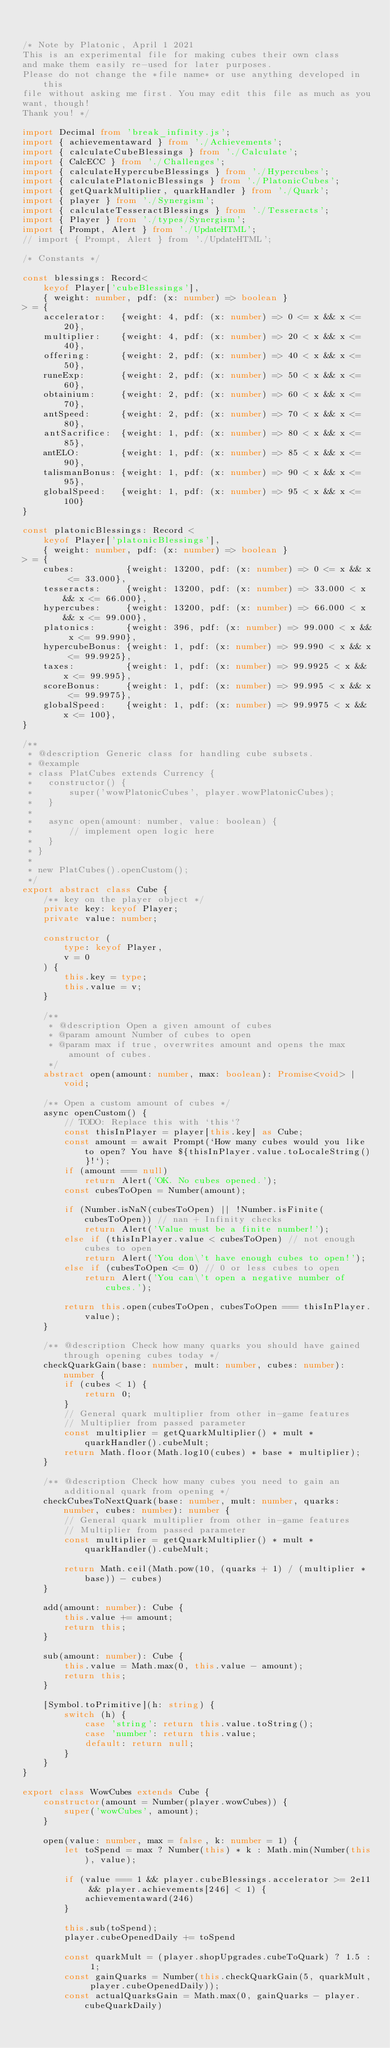Convert code to text. <code><loc_0><loc_0><loc_500><loc_500><_TypeScript_>

/* Note by Platonic, April 1 2021
This is an experimental file for making cubes their own class
and make them easily re-used for later purposes.
Please do not change the *file name* or use anything developed in this
file without asking me first. You may edit this file as much as you
want, though!
Thank you! */

import Decimal from 'break_infinity.js';
import { achievementaward } from './Achievements';
import { calculateCubeBlessings } from './Calculate';
import { CalcECC } from './Challenges';
import { calculateHypercubeBlessings } from './Hypercubes';
import { calculatePlatonicBlessings } from './PlatonicCubes';
import { getQuarkMultiplier, quarkHandler } from './Quark';
import { player } from './Synergism';
import { calculateTesseractBlessings } from './Tesseracts';
import { Player } from './types/Synergism';
import { Prompt, Alert } from './UpdateHTML';
// import { Prompt, Alert } from './UpdateHTML';

/* Constants */

const blessings: Record<
    keyof Player['cubeBlessings'], 
    { weight: number, pdf: (x: number) => boolean }
> = {
    accelerator:   {weight: 4, pdf: (x: number) => 0 <= x && x <= 20},
    multiplier:    {weight: 4, pdf: (x: number) => 20 < x && x <= 40},
    offering:      {weight: 2, pdf: (x: number) => 40 < x && x <= 50},
    runeExp:       {weight: 2, pdf: (x: number) => 50 < x && x <= 60},
    obtainium:     {weight: 2, pdf: (x: number) => 60 < x && x <= 70},
    antSpeed:      {weight: 2, pdf: (x: number) => 70 < x && x <= 80},
    antSacrifice:  {weight: 1, pdf: (x: number) => 80 < x && x <= 85},
    antELO:        {weight: 1, pdf: (x: number) => 85 < x && x <= 90},
    talismanBonus: {weight: 1, pdf: (x: number) => 90 < x && x <= 95},
    globalSpeed:   {weight: 1, pdf: (x: number) => 95 < x && x <= 100}
}

const platonicBlessings: Record <
    keyof Player['platonicBlessings'],
    { weight: number, pdf: (x: number) => boolean }
> = {
    cubes:          {weight: 13200, pdf: (x: number) => 0 <= x && x <= 33.000},
    tesseracts:     {weight: 13200, pdf: (x: number) => 33.000 < x && x <= 66.000},
    hypercubes:     {weight: 13200, pdf: (x: number) => 66.000 < x && x <= 99.000},
    platonics:      {weight: 396, pdf: (x: number) => 99.000 < x && x <= 99.990},
    hypercubeBonus: {weight: 1, pdf: (x: number) => 99.990 < x && x <= 99.9925},
    taxes:          {weight: 1, pdf: (x: number) => 99.9925 < x && x <= 99.995},
    scoreBonus:     {weight: 1, pdf: (x: number) => 99.995 < x && x <= 99.9975},
    globalSpeed:    {weight: 1, pdf: (x: number) => 99.9975 < x && x <= 100},
}

/**
 * @description Generic class for handling cube subsets.
 * @example
 * class PlatCubes extends Currency {
 *   constructor() {
 *       super('wowPlatonicCubes', player.wowPlatonicCubes);
 *   }
 *
 *   async open(amount: number, value: boolean) {
 *       // implement open logic here
 *   }
 * }
 * 
 * new PlatCubes().openCustom(); 
 */
export abstract class Cube {
    /** key on the player object */
    private key: keyof Player;
    private value: number;

    constructor (
        type: keyof Player,
        v = 0
    ) {
        this.key = type;
        this.value = v;
    }

    /**
     * @description Open a given amount of cubes
     * @param amount Number of cubes to open
     * @param max if true, overwrites amount and opens the max amount of cubes.
     */
    abstract open(amount: number, max: boolean): Promise<void> | void;

    /** Open a custom amount of cubes */
    async openCustom() {
        // TODO: Replace this with `this`?
        const thisInPlayer = player[this.key] as Cube;
        const amount = await Prompt(`How many cubes would you like to open? You have ${thisInPlayer.value.toLocaleString()}!`);
        if (amount === null)
            return Alert('OK. No cubes opened.');
        const cubesToOpen = Number(amount);

        if (Number.isNaN(cubesToOpen) || !Number.isFinite(cubesToOpen)) // nan + Infinity checks
            return Alert('Value must be a finite number!');
        else if (thisInPlayer.value < cubesToOpen) // not enough cubes to open
            return Alert('You don\'t have enough cubes to open!');
        else if (cubesToOpen <= 0) // 0 or less cubes to open
            return Alert('You can\'t open a negative number of cubes.');

        return this.open(cubesToOpen, cubesToOpen === thisInPlayer.value);
    }

    /** @description Check how many quarks you should have gained through opening cubes today */
    checkQuarkGain(base: number, mult: number, cubes: number): number {
        if (cubes < 1) {
            return 0;
        }
        // General quark multiplier from other in-game features
        // Multiplier from passed parameter
        const multiplier = getQuarkMultiplier() * mult * quarkHandler().cubeMult;
        return Math.floor(Math.log10(cubes) * base * multiplier);
    }

    /** @description Check how many cubes you need to gain an additional quark from opening */
    checkCubesToNextQuark(base: number, mult: number, quarks: number, cubes: number): number {
        // General quark multiplier from other in-game features
        // Multiplier from passed parameter
        const multiplier = getQuarkMultiplier() * mult * quarkHandler().cubeMult;

        return Math.ceil(Math.pow(10, (quarks + 1) / (multiplier * base)) - cubes)
    }

    add(amount: number): Cube {
        this.value += amount;
        return this;
    }

    sub(amount: number): Cube {
        this.value = Math.max(0, this.value - amount);
        return this;
    }

    [Symbol.toPrimitive](h: string) {
        switch (h) {
            case 'string': return this.value.toString();
            case 'number': return this.value;
            default: return null;
        }
    }
}

export class WowCubes extends Cube {
    constructor(amount = Number(player.wowCubes)) {
        super('wowCubes', amount);
    }

    open(value: number, max = false, k: number = 1) {
        let toSpend = max ? Number(this) * k : Math.min(Number(this), value);

        if (value === 1 && player.cubeBlessings.accelerator >= 2e11 && player.achievements[246] < 1) {
            achievementaward(246)
        }

        this.sub(toSpend);
        player.cubeOpenedDaily += toSpend

        const quarkMult = (player.shopUpgrades.cubeToQuark) ? 1.5 : 1;
        const gainQuarks = Number(this.checkQuarkGain(5, quarkMult, player.cubeOpenedDaily));
        const actualQuarksGain = Math.max(0, gainQuarks - player.cubeQuarkDaily)</code> 